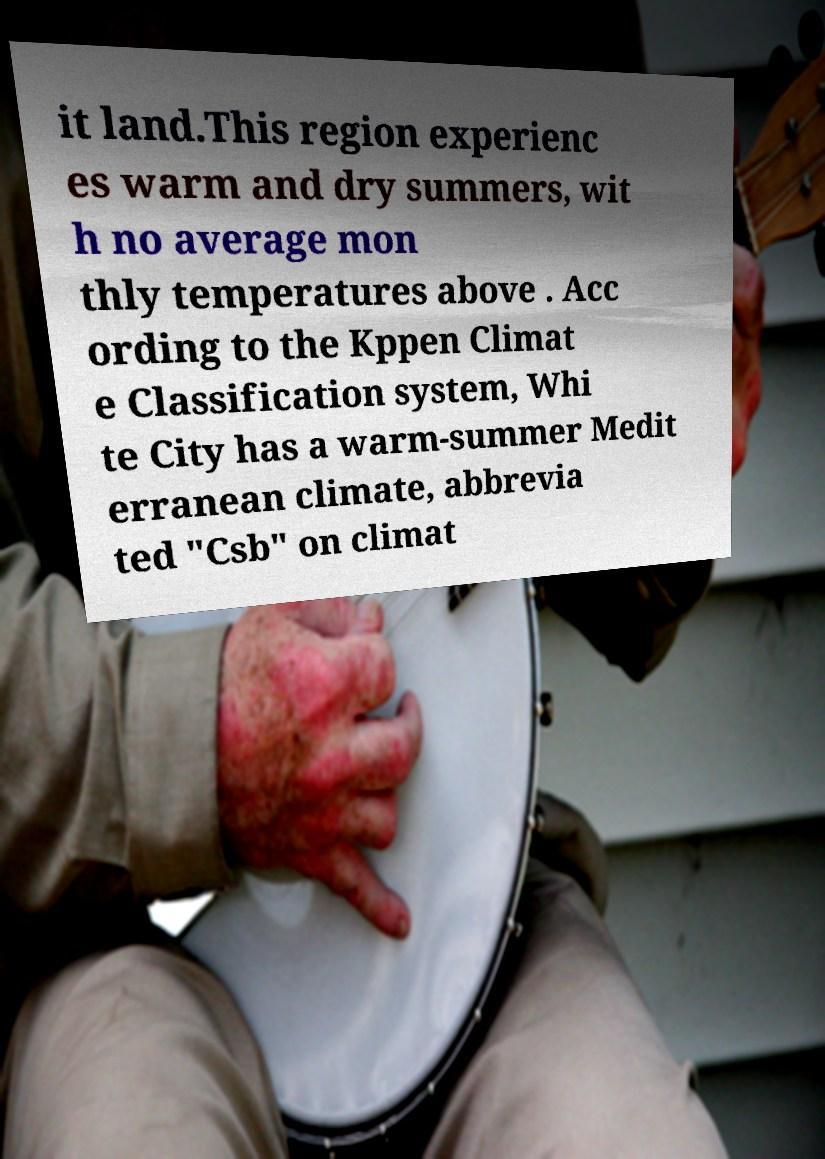I need the written content from this picture converted into text. Can you do that? it land.This region experienc es warm and dry summers, wit h no average mon thly temperatures above . Acc ording to the Kppen Climat e Classification system, Whi te City has a warm-summer Medit erranean climate, abbrevia ted "Csb" on climat 